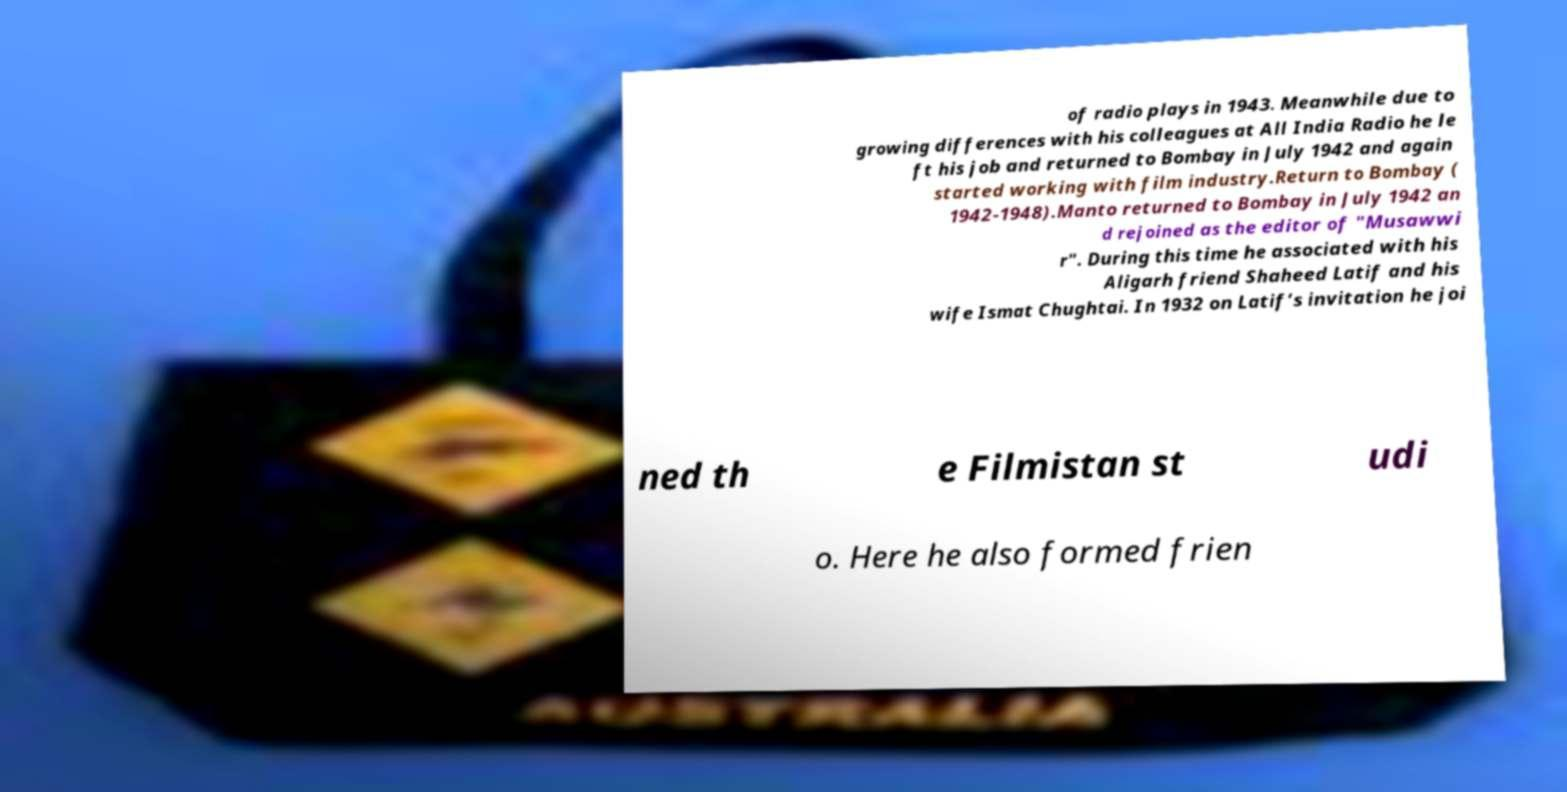Can you read and provide the text displayed in the image?This photo seems to have some interesting text. Can you extract and type it out for me? of radio plays in 1943. Meanwhile due to growing differences with his colleagues at All India Radio he le ft his job and returned to Bombay in July 1942 and again started working with film industry.Return to Bombay ( 1942-1948).Manto returned to Bombay in July 1942 an d rejoined as the editor of "Musawwi r". During this time he associated with his Aligarh friend Shaheed Latif and his wife Ismat Chughtai. In 1932 on Latif’s invitation he joi ned th e Filmistan st udi o. Here he also formed frien 